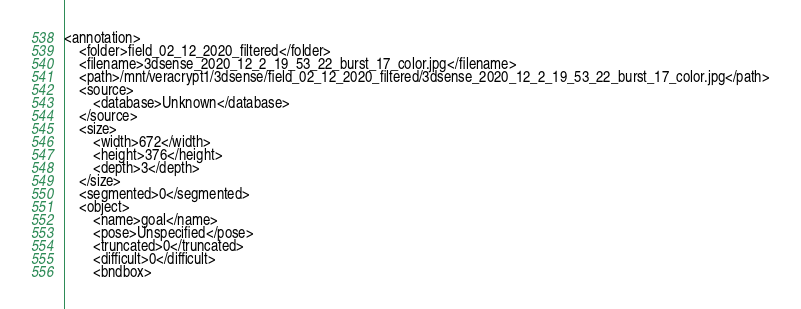Convert code to text. <code><loc_0><loc_0><loc_500><loc_500><_XML_><annotation>
	<folder>field_02_12_2020_filtered</folder>
	<filename>3dsense_2020_12_2_19_53_22_burst_17_color.jpg</filename>
	<path>/mnt/veracrypt1/3dsense/field_02_12_2020_filtered/3dsense_2020_12_2_19_53_22_burst_17_color.jpg</path>
	<source>
		<database>Unknown</database>
	</source>
	<size>
		<width>672</width>
		<height>376</height>
		<depth>3</depth>
	</size>
	<segmented>0</segmented>
	<object>
		<name>goal</name>
		<pose>Unspecified</pose>
		<truncated>0</truncated>
		<difficult>0</difficult>
		<bndbox></code> 